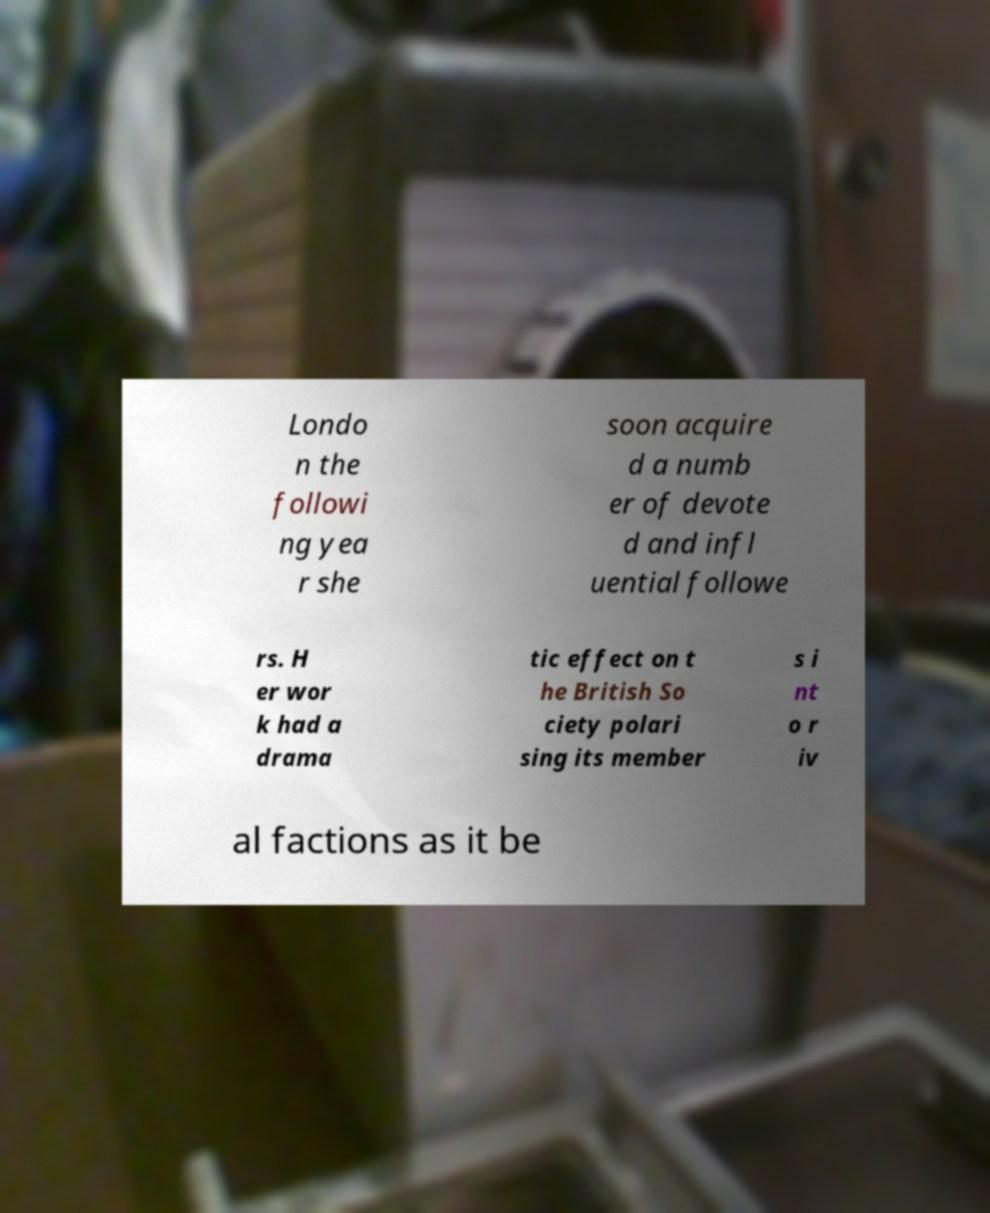Could you extract and type out the text from this image? Londo n the followi ng yea r she soon acquire d a numb er of devote d and infl uential followe rs. H er wor k had a drama tic effect on t he British So ciety polari sing its member s i nt o r iv al factions as it be 